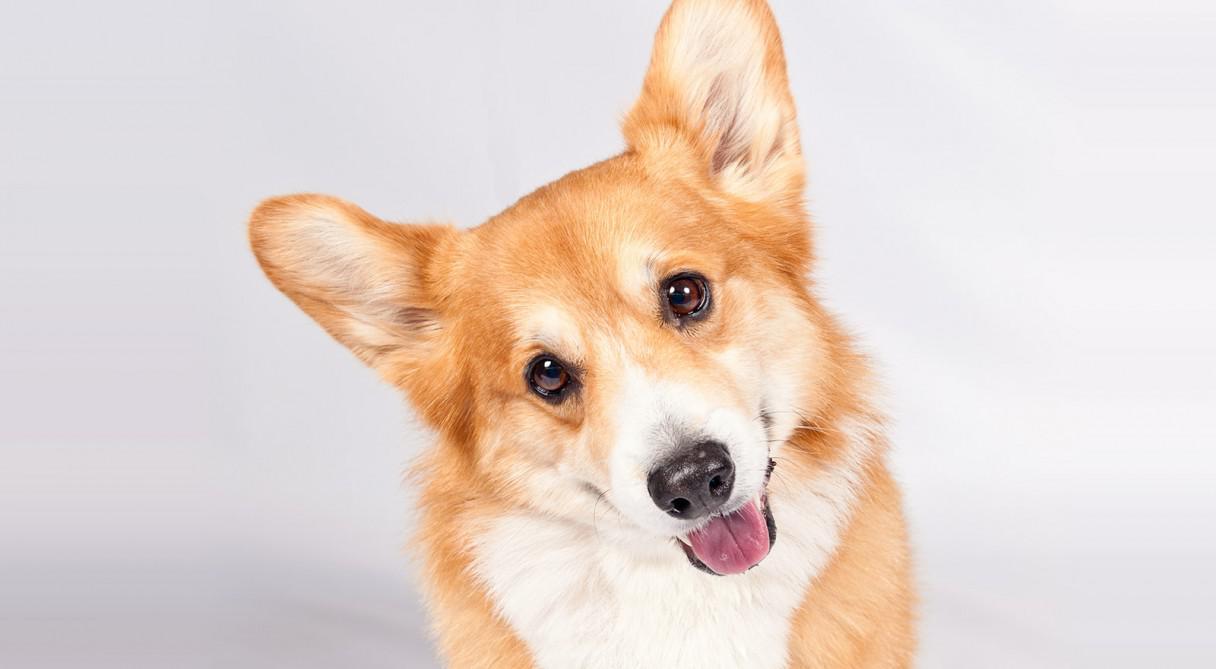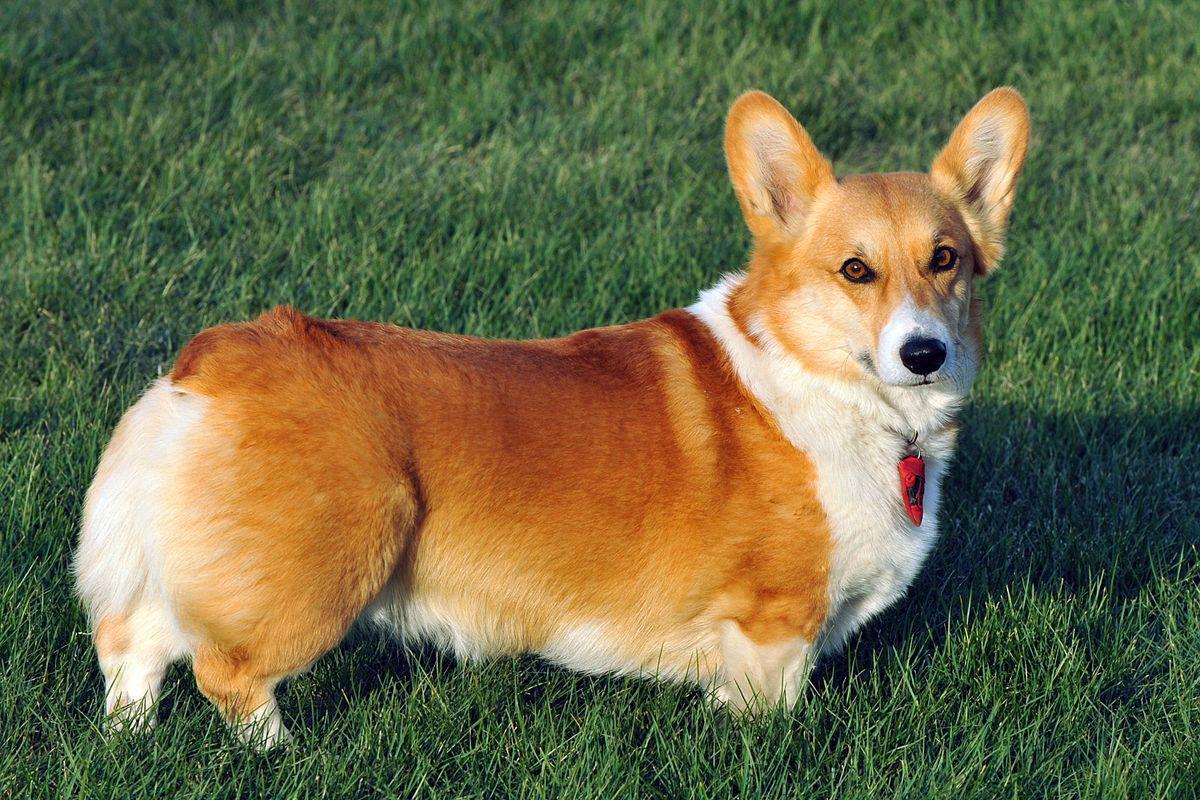The first image is the image on the left, the second image is the image on the right. Assess this claim about the two images: "There is a sitting dog in one of the images.". Correct or not? Answer yes or no. No. 